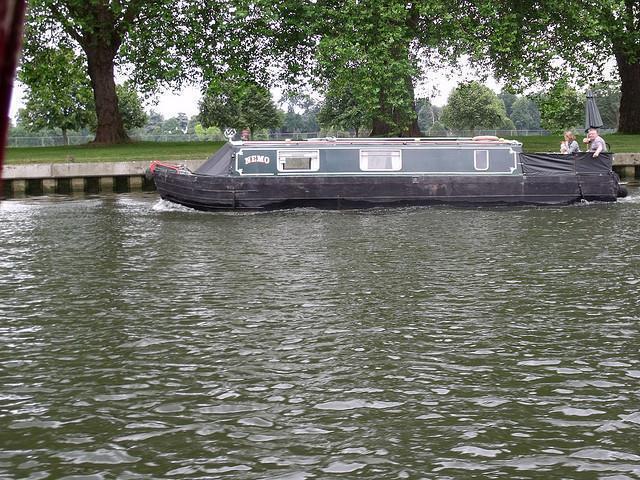What does the word on the boat relate?
Choose the correct response, then elucidate: 'Answer: answer
Rationale: rationale.'
Options: Song, movie, bus, book. Answer: movie.
Rationale: The word on the boat is nemo. there is a well-known disney full length animated feature called finding nemo. however, there is also a character called captain nemo in a book. 